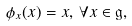<formula> <loc_0><loc_0><loc_500><loc_500>\phi _ { x } ( x ) = x , \, \forall x \in \mathfrak { g } ,</formula> 